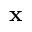<formula> <loc_0><loc_0><loc_500><loc_500>x</formula> 